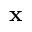<formula> <loc_0><loc_0><loc_500><loc_500>x</formula> 